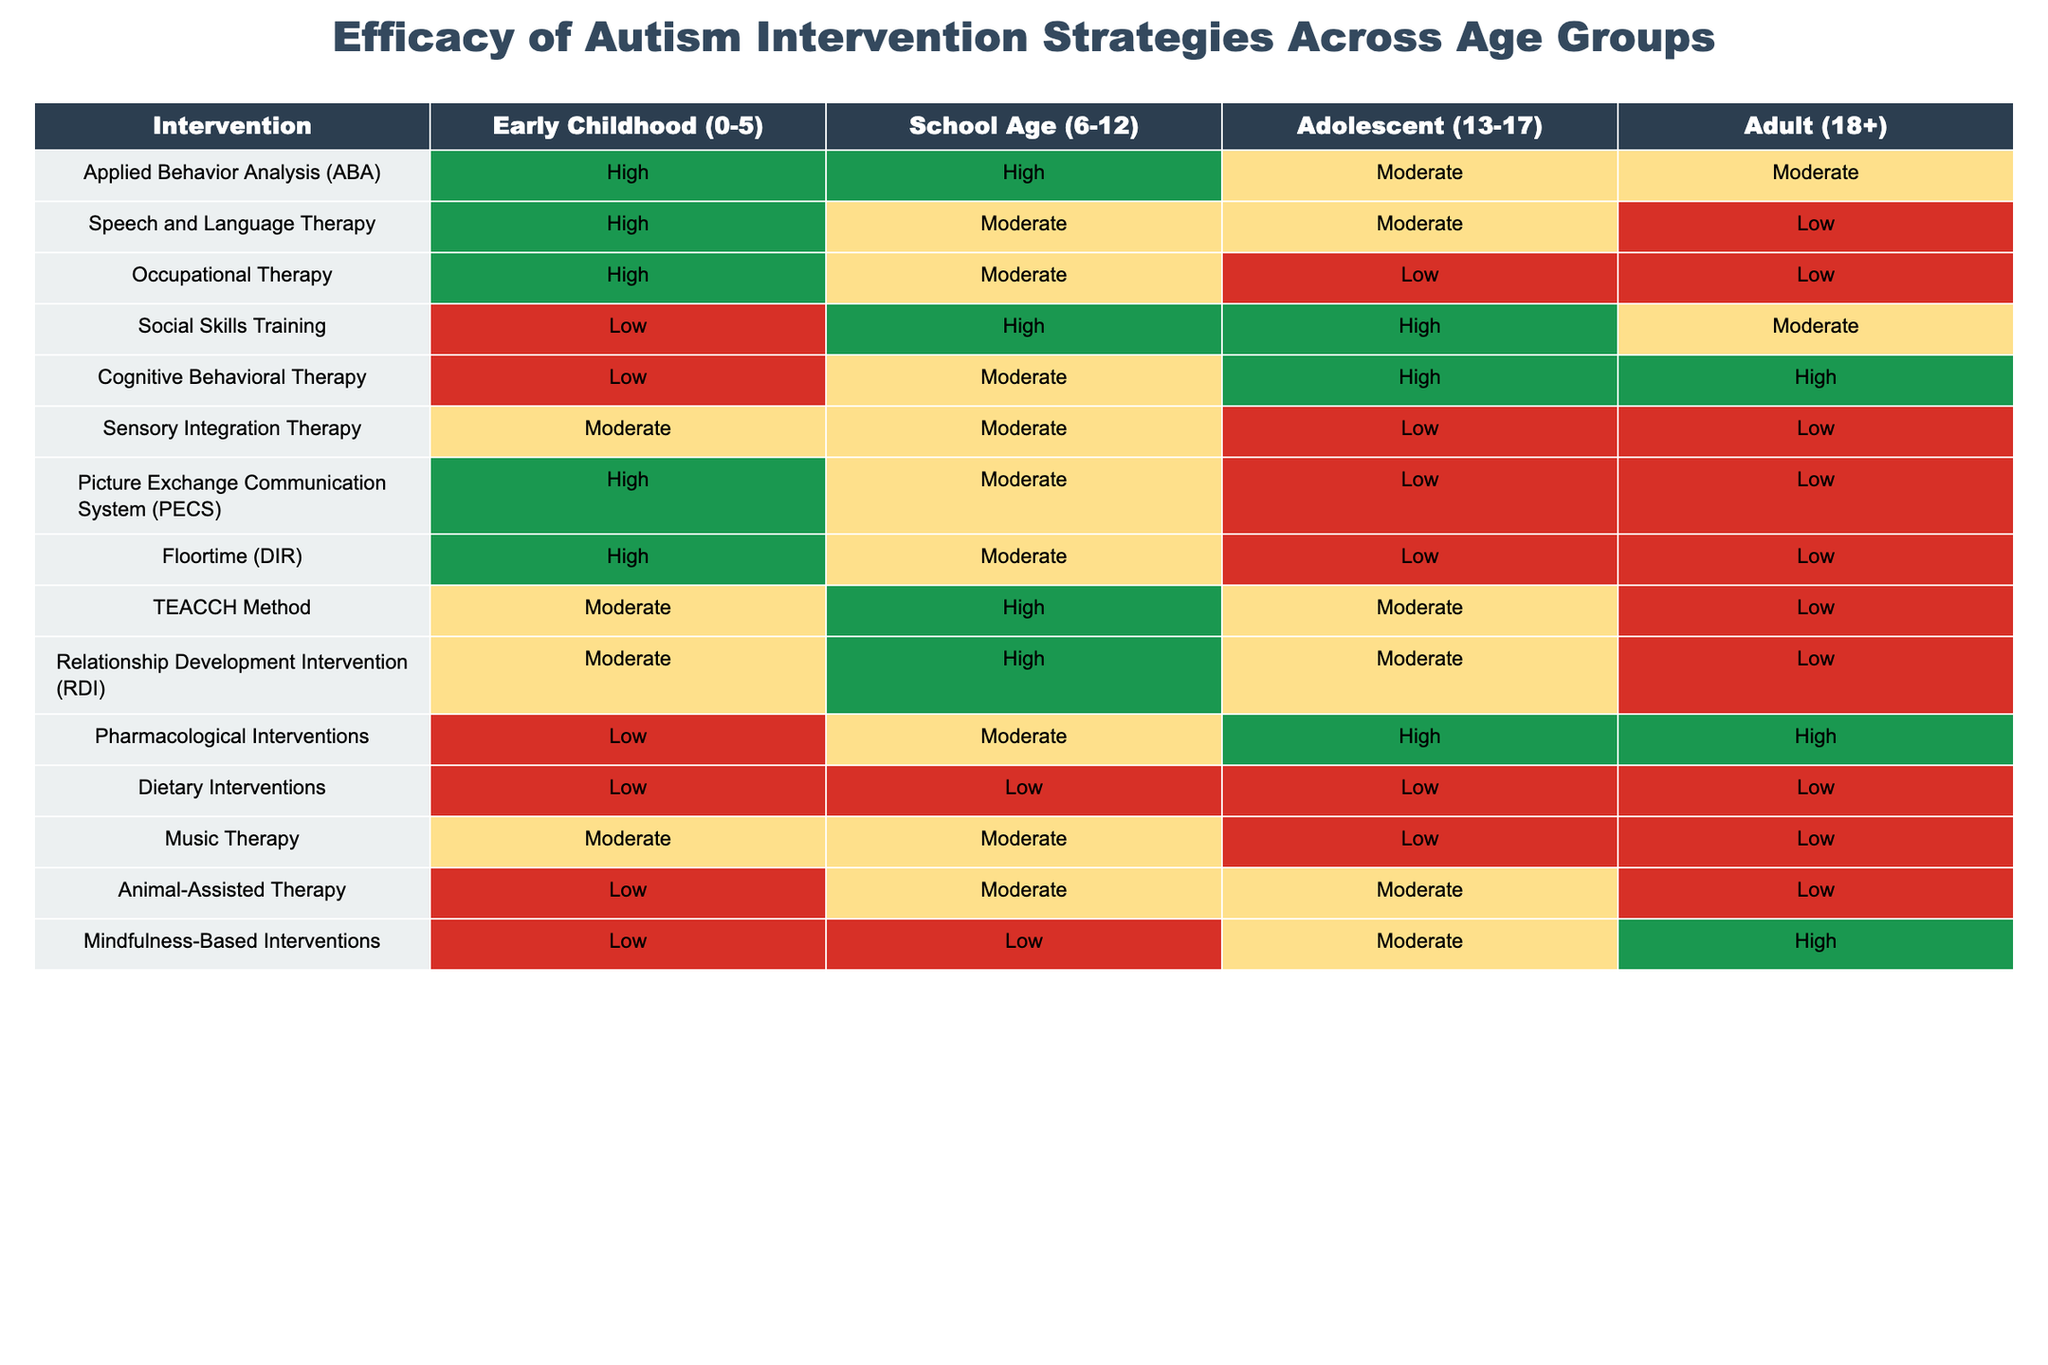What is the efficacy of Applied Behavior Analysis in Adults (18+)? According to the table, the efficacy of Applied Behavior Analysis in the Adult category is rated as Moderate.
Answer: Moderate Which therapy type has the highest efficacy rating among School Age children (6-12)? Reviewing the School Age column, the therapies listed with High efficacy are Applied Behavior Analysis and Social Skills Training. Hence, both therapies have the same highest rating.
Answer: Applied Behavior Analysis and Social Skills Training Is Occupational Therapy rated higher than Speech and Language Therapy for Adolescents? Looking at the Adolescents column, Occupational Therapy is rated Low while Speech and Language Therapy is rated Moderate. Therefore, Occupational Therapy is not rated higher.
Answer: No What is the average efficacy rating for Cognitive Behavioral Therapy across all age groups? The efficacy ratings for Cognitive Behavioral Therapy across age groups are Low, Moderate, High, and High, which can be translated to numerical values: Low=1, Moderate=2, High=3. The sum is (1 + 2 + 3 + 3) = 9. There are 4 age groups, therefore the average is 9/4 = 2.25, which corresponds to Moderate.
Answer: Moderate Do all therapies have at least a Moderate rating for Early Childhood intervention? In the Early Childhood column, the therapies with the efficacy ratings include: Applied Behavior Analysis (High), Speech and Language Therapy (High), Occupational Therapy (High), Social Skills Training (Low), Cognitive Behavioral Therapy (Low), Sensory Integration Therapy (Moderate), Picture Exchange Communication System (PECS) (High), Floortime (DIR) (High), TEACCH Method (Moderate), Relationship Development Intervention (RDI) (Moderate), Pharmacological Interventions (Low), Dietary Interventions (Low), Music Therapy (Moderate), Animal-Assisted Therapy (Low), and Mindfulness-Based Interventions (Low). Since there are therapies that are rated Low, the statement is false.
Answer: No What is the difference in efficacy ratings between Speech and Language Therapy in Early Childhood and Music Therapy in Adolescents? In Early Childhood, Speech and Language Therapy is rated High (3), and in Adolescents, Music Therapy is rated Low (1). The difference between the two ratings is calculated as 3 - 1 = 2. This means Speech and Language Therapy has a higher efficacy rating.
Answer: 2 